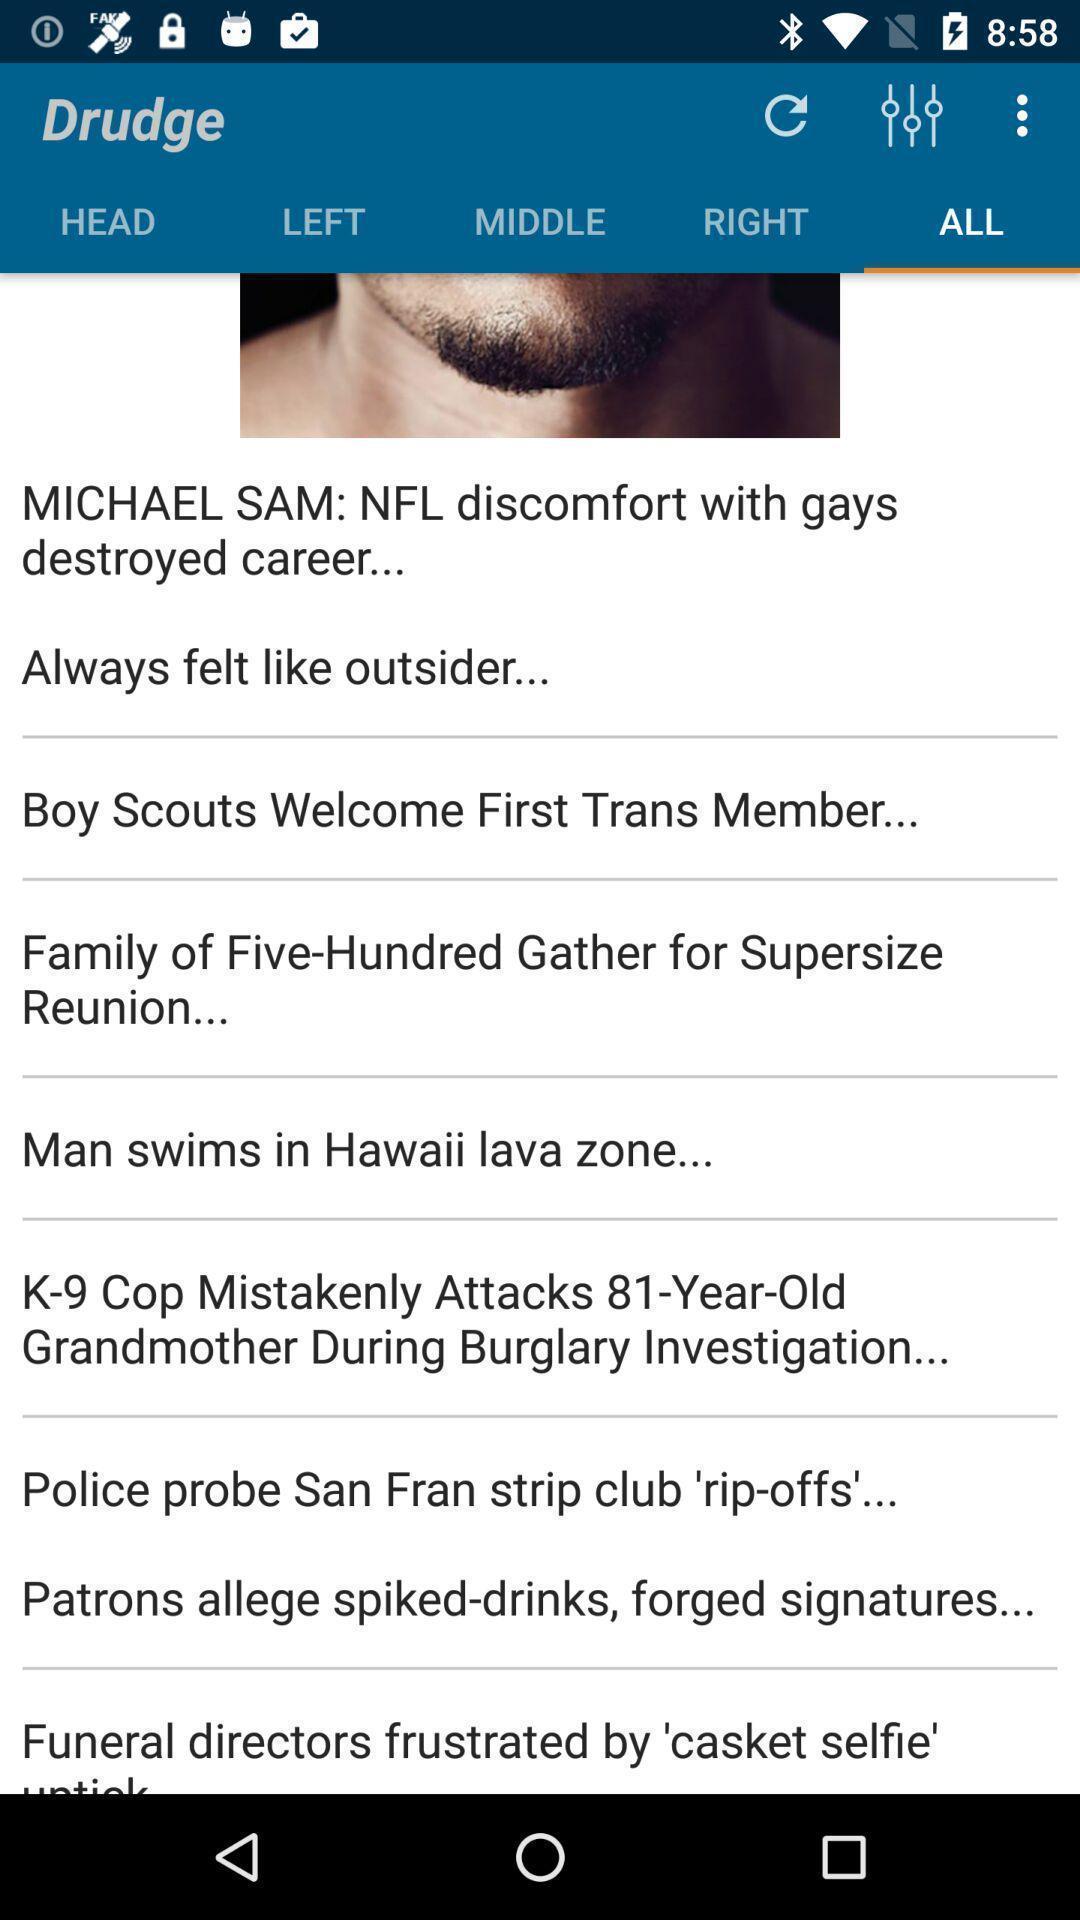Please provide a description for this image. Various info page displayed. 